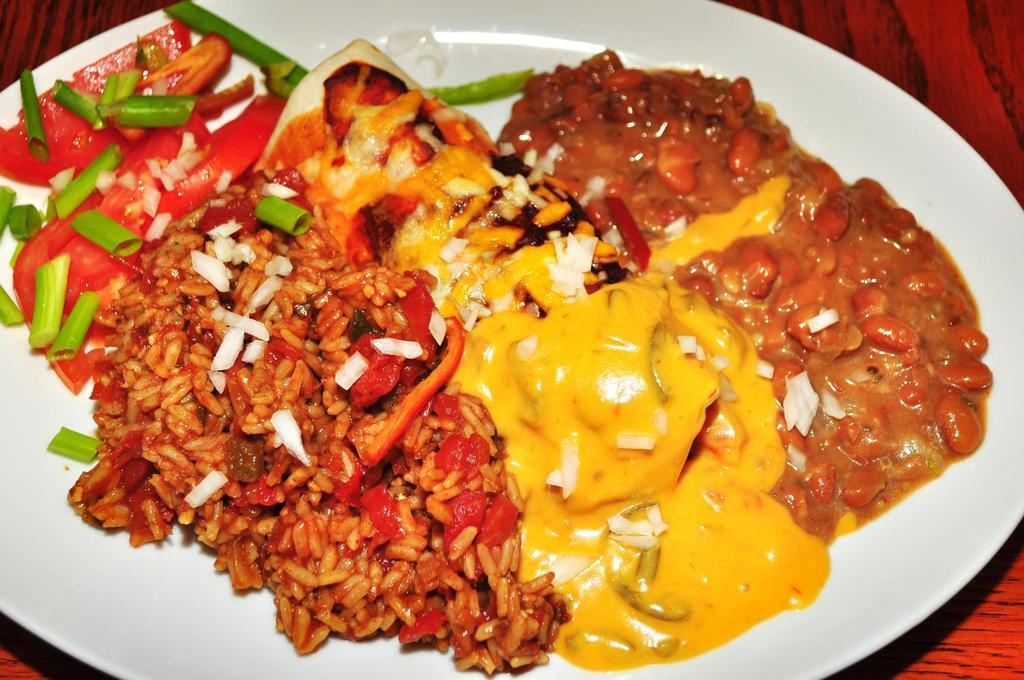What is on the plate that is visible in the image? There are food items on a plate in the image. What color is the plate? The plate is white in color. What type of surface is the plate resting on? The plate is on a wooden surface. Can you see any stems on the food items in the image? There is no information about stems on the food items in the image, so it cannot be determined from the image. 